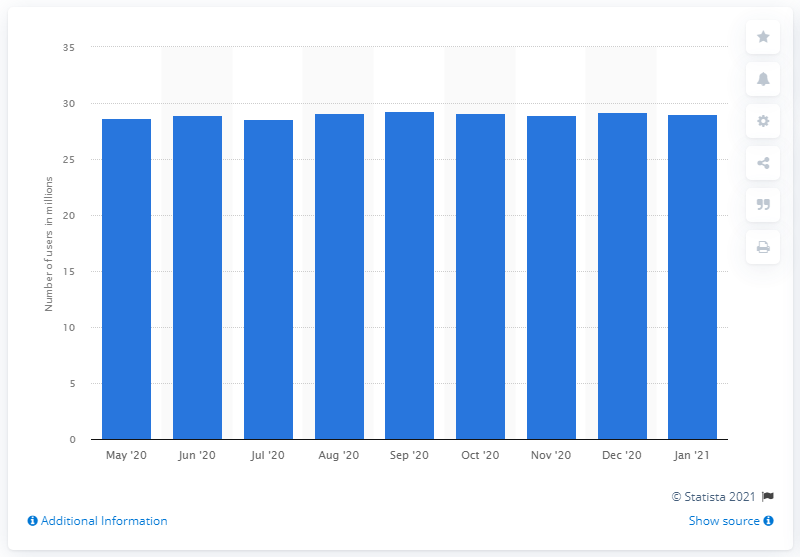Point out several critical features in this image. In January 2021, there were approximately 29.06 people in Argentina who used Facebook Messenger. 